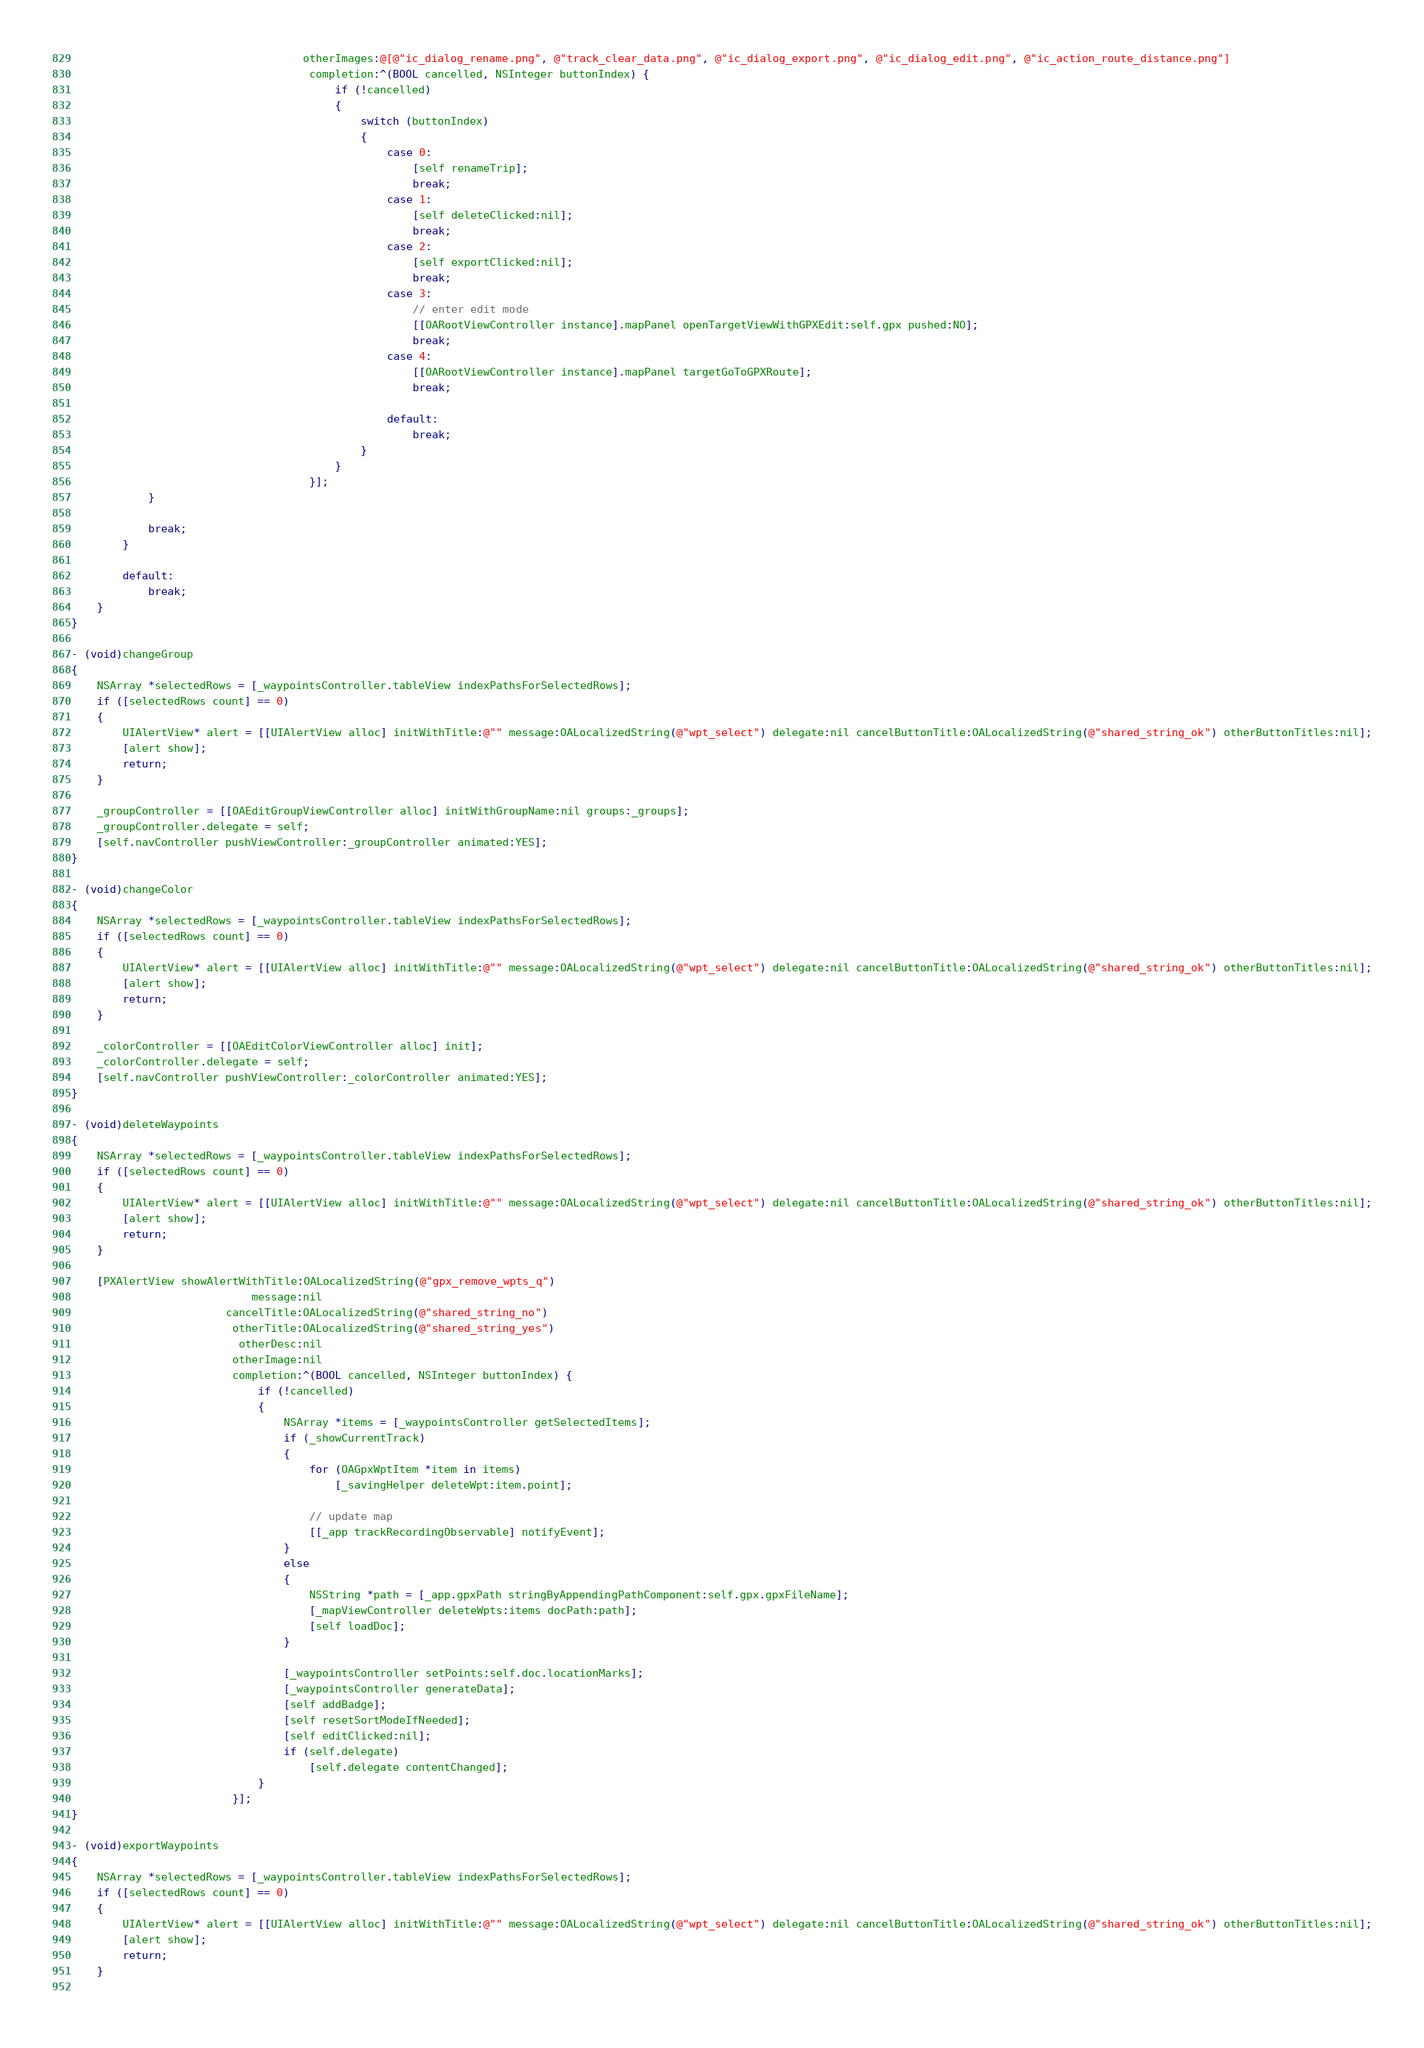<code> <loc_0><loc_0><loc_500><loc_500><_ObjectiveC_>                                    otherImages:@[@"ic_dialog_rename.png", @"track_clear_data.png", @"ic_dialog_export.png", @"ic_dialog_edit.png", @"ic_action_route_distance.png"]
                                     completion:^(BOOL cancelled, NSInteger buttonIndex) {
                                         if (!cancelled)
                                         {
                                             switch (buttonIndex)
                                             {
                                                 case 0:
                                                     [self renameTrip];
                                                     break;
                                                 case 1:
                                                     [self deleteClicked:nil];
                                                     break;
                                                 case 2:
                                                     [self exportClicked:nil];
                                                     break;
                                                 case 3:
                                                     // enter edit mode
                                                     [[OARootViewController instance].mapPanel openTargetViewWithGPXEdit:self.gpx pushed:NO];
                                                     break;
                                                 case 4:
                                                     [[OARootViewController instance].mapPanel targetGoToGPXRoute];
                                                     break;

                                                 default:
                                                     break;
                                             }
                                         }
                                     }];
            }
            
            break;
        }
            
        default:
            break;
    }
}

- (void)changeGroup
{
    NSArray *selectedRows = [_waypointsController.tableView indexPathsForSelectedRows];
    if ([selectedRows count] == 0)
    {
        UIAlertView* alert = [[UIAlertView alloc] initWithTitle:@"" message:OALocalizedString(@"wpt_select") delegate:nil cancelButtonTitle:OALocalizedString(@"shared_string_ok") otherButtonTitles:nil];
        [alert show];
        return;
    }
    
    _groupController = [[OAEditGroupViewController alloc] initWithGroupName:nil groups:_groups];
    _groupController.delegate = self;
    [self.navController pushViewController:_groupController animated:YES];
}

- (void)changeColor
{
    NSArray *selectedRows = [_waypointsController.tableView indexPathsForSelectedRows];
    if ([selectedRows count] == 0)
    {
        UIAlertView* alert = [[UIAlertView alloc] initWithTitle:@"" message:OALocalizedString(@"wpt_select") delegate:nil cancelButtonTitle:OALocalizedString(@"shared_string_ok") otherButtonTitles:nil];
        [alert show];
        return;
    }
    
    _colorController = [[OAEditColorViewController alloc] init];
    _colorController.delegate = self;
    [self.navController pushViewController:_colorController animated:YES];
}

- (void)deleteWaypoints
{
    NSArray *selectedRows = [_waypointsController.tableView indexPathsForSelectedRows];
    if ([selectedRows count] == 0)
    {
        UIAlertView* alert = [[UIAlertView alloc] initWithTitle:@"" message:OALocalizedString(@"wpt_select") delegate:nil cancelButtonTitle:OALocalizedString(@"shared_string_ok") otherButtonTitles:nil];
        [alert show];
        return;
    }
    
    [PXAlertView showAlertWithTitle:OALocalizedString(@"gpx_remove_wpts_q")
                            message:nil
                        cancelTitle:OALocalizedString(@"shared_string_no")
                         otherTitle:OALocalizedString(@"shared_string_yes")
                          otherDesc:nil
                         otherImage:nil
                         completion:^(BOOL cancelled, NSInteger buttonIndex) {
                             if (!cancelled)
                             {
                                 NSArray *items = [_waypointsController getSelectedItems];
                                 if (_showCurrentTrack)
                                 {
                                     for (OAGpxWptItem *item in items)
                                         [_savingHelper deleteWpt:item.point];

                                     // update map
                                     [[_app trackRecordingObservable] notifyEvent];
                                 }
                                 else
                                 {
                                     NSString *path = [_app.gpxPath stringByAppendingPathComponent:self.gpx.gpxFileName];
                                     [_mapViewController deleteWpts:items docPath:path];
                                     [self loadDoc];
                                 }

                                 [_waypointsController setPoints:self.doc.locationMarks];
                                 [_waypointsController generateData];
                                 [self addBadge];
                                 [self resetSortModeIfNeeded];
                                 [self editClicked:nil];
                                 if (self.delegate)
                                     [self.delegate contentChanged];
                             }
                         }];
}

- (void)exportWaypoints
{
    NSArray *selectedRows = [_waypointsController.tableView indexPathsForSelectedRows];
    if ([selectedRows count] == 0)
    {
        UIAlertView* alert = [[UIAlertView alloc] initWithTitle:@"" message:OALocalizedString(@"wpt_select") delegate:nil cancelButtonTitle:OALocalizedString(@"shared_string_ok") otherButtonTitles:nil];
        [alert show];
        return;
    }
    </code> 